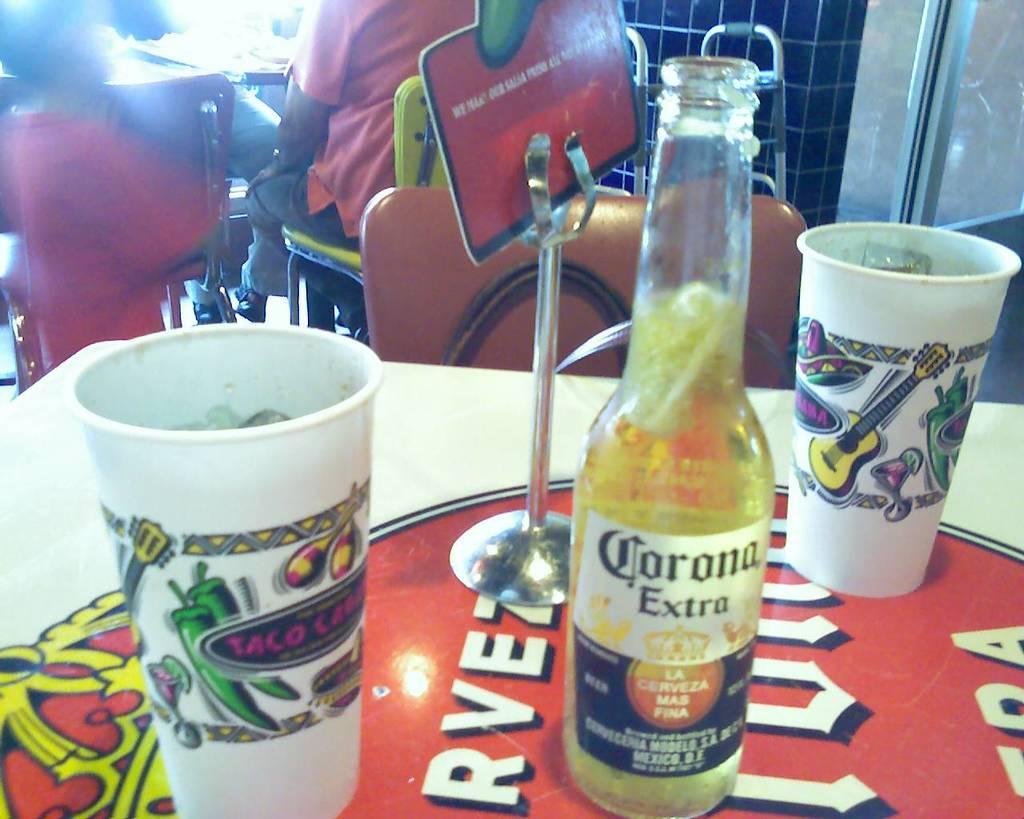Can you describe this image briefly? This is the picture of a table and on the table we have two glasses,bottle and a stand. 